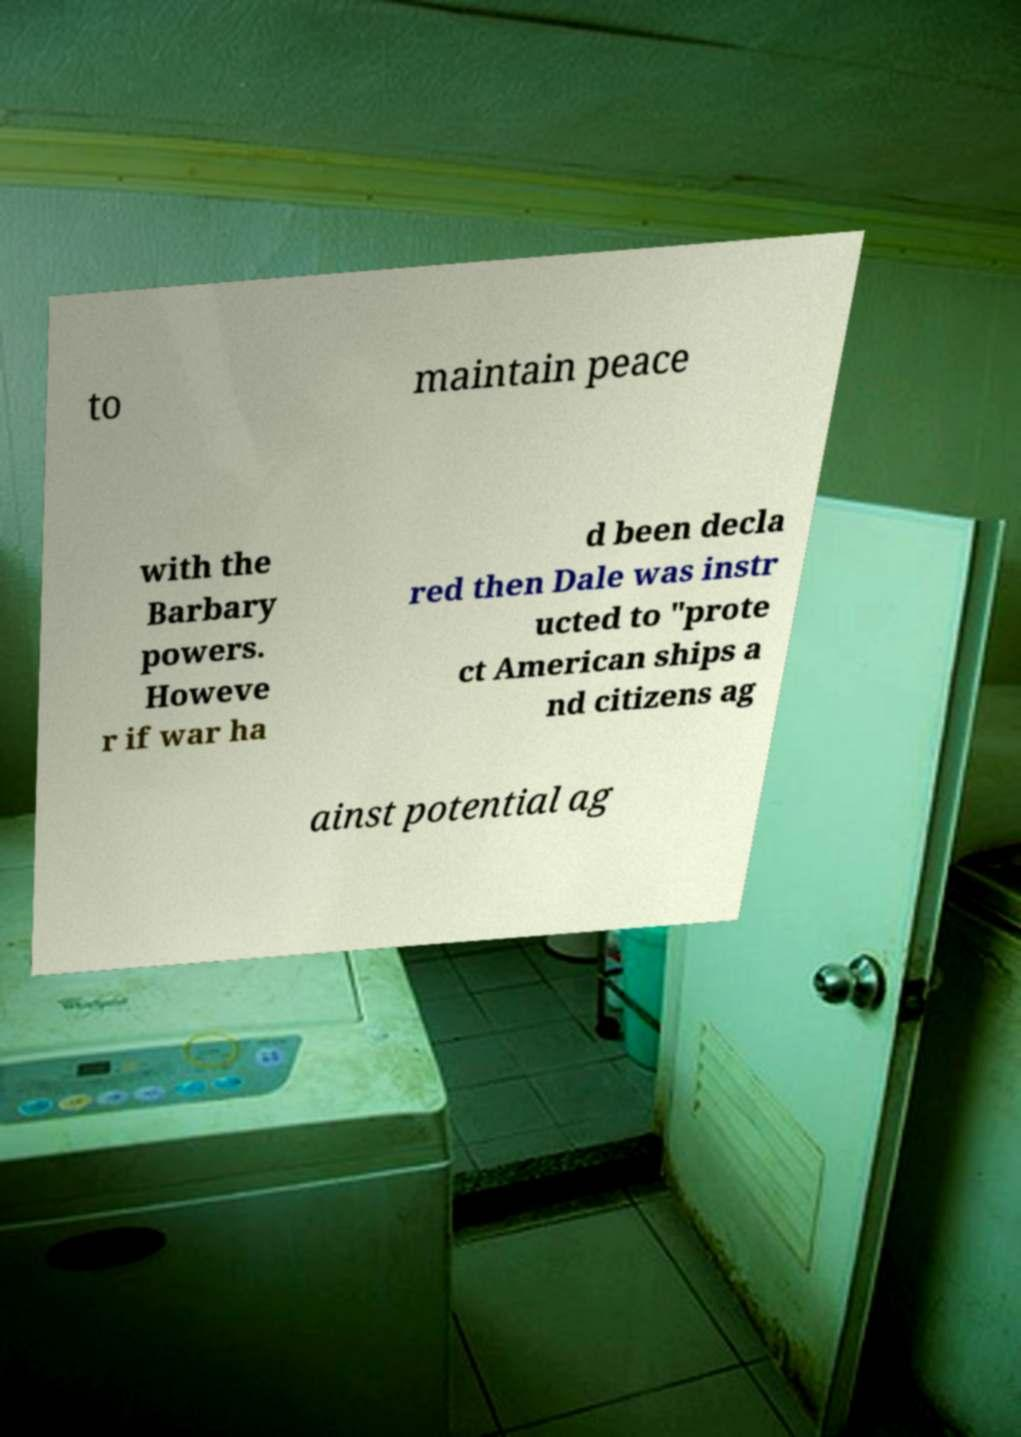There's text embedded in this image that I need extracted. Can you transcribe it verbatim? to maintain peace with the Barbary powers. Howeve r if war ha d been decla red then Dale was instr ucted to "prote ct American ships a nd citizens ag ainst potential ag 